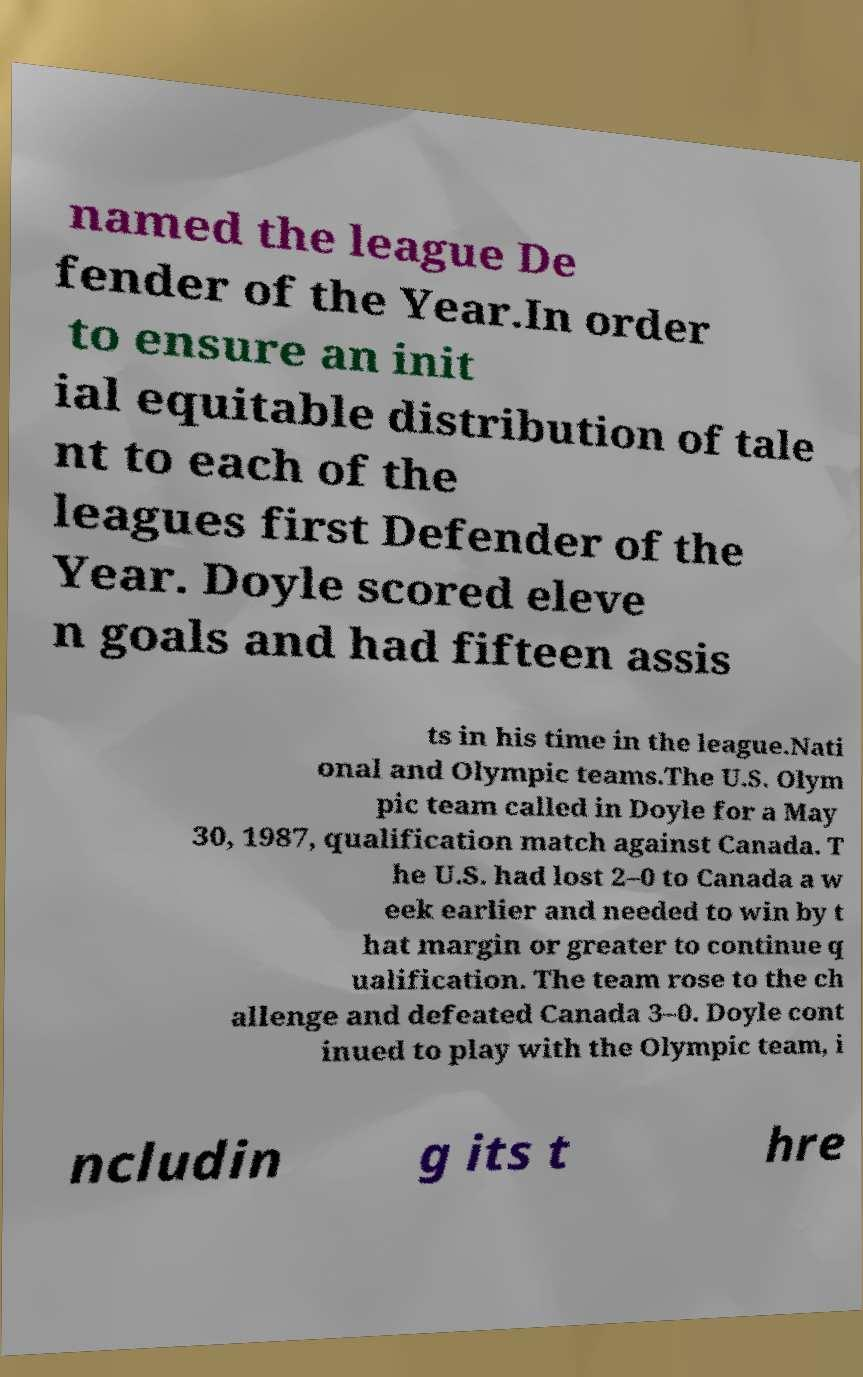There's text embedded in this image that I need extracted. Can you transcribe it verbatim? named the league De fender of the Year.In order to ensure an init ial equitable distribution of tale nt to each of the leagues first Defender of the Year. Doyle scored eleve n goals and had fifteen assis ts in his time in the league.Nati onal and Olympic teams.The U.S. Olym pic team called in Doyle for a May 30, 1987, qualification match against Canada. T he U.S. had lost 2–0 to Canada a w eek earlier and needed to win by t hat margin or greater to continue q ualification. The team rose to the ch allenge and defeated Canada 3–0. Doyle cont inued to play with the Olympic team, i ncludin g its t hre 